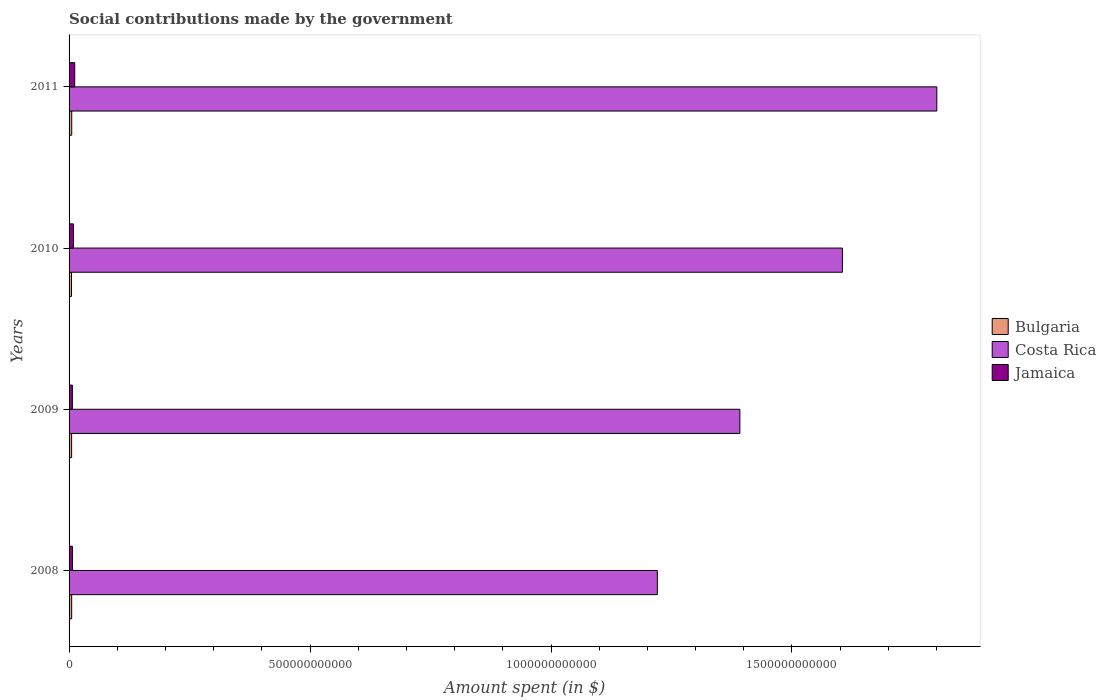How many different coloured bars are there?
Give a very brief answer. 3. How many groups of bars are there?
Offer a terse response. 4. What is the label of the 1st group of bars from the top?
Provide a short and direct response. 2011. In how many cases, is the number of bars for a given year not equal to the number of legend labels?
Offer a very short reply. 0. What is the amount spent on social contributions in Jamaica in 2010?
Make the answer very short. 9.20e+09. Across all years, what is the maximum amount spent on social contributions in Jamaica?
Offer a very short reply. 1.17e+1. Across all years, what is the minimum amount spent on social contributions in Jamaica?
Your response must be concise. 6.87e+09. In which year was the amount spent on social contributions in Costa Rica maximum?
Give a very brief answer. 2011. In which year was the amount spent on social contributions in Costa Rica minimum?
Provide a succinct answer. 2008. What is the total amount spent on social contributions in Jamaica in the graph?
Provide a short and direct response. 3.48e+1. What is the difference between the amount spent on social contributions in Bulgaria in 2008 and that in 2011?
Your answer should be very brief. -1.40e+08. What is the difference between the amount spent on social contributions in Bulgaria in 2010 and the amount spent on social contributions in Costa Rica in 2009?
Give a very brief answer. -1.39e+12. What is the average amount spent on social contributions in Jamaica per year?
Give a very brief answer. 8.71e+09. In the year 2008, what is the difference between the amount spent on social contributions in Costa Rica and amount spent on social contributions in Jamaica?
Make the answer very short. 1.21e+12. In how many years, is the amount spent on social contributions in Jamaica greater than 1100000000000 $?
Offer a terse response. 0. What is the ratio of the amount spent on social contributions in Bulgaria in 2009 to that in 2010?
Your response must be concise. 1.06. What is the difference between the highest and the second highest amount spent on social contributions in Bulgaria?
Give a very brief answer. 1.40e+08. What is the difference between the highest and the lowest amount spent on social contributions in Costa Rica?
Your answer should be compact. 5.80e+11. Is the sum of the amount spent on social contributions in Costa Rica in 2009 and 2011 greater than the maximum amount spent on social contributions in Bulgaria across all years?
Your response must be concise. Yes. What does the 1st bar from the top in 2008 represents?
Provide a succinct answer. Jamaica. What does the 1st bar from the bottom in 2008 represents?
Provide a short and direct response. Bulgaria. Is it the case that in every year, the sum of the amount spent on social contributions in Costa Rica and amount spent on social contributions in Bulgaria is greater than the amount spent on social contributions in Jamaica?
Provide a short and direct response. Yes. How many bars are there?
Your answer should be very brief. 12. Are all the bars in the graph horizontal?
Offer a very short reply. Yes. What is the difference between two consecutive major ticks on the X-axis?
Your answer should be very brief. 5.00e+11. Are the values on the major ticks of X-axis written in scientific E-notation?
Your response must be concise. No. Does the graph contain grids?
Your response must be concise. No. How many legend labels are there?
Your answer should be very brief. 3. How are the legend labels stacked?
Offer a terse response. Vertical. What is the title of the graph?
Your answer should be very brief. Social contributions made by the government. Does "Tanzania" appear as one of the legend labels in the graph?
Ensure brevity in your answer.  No. What is the label or title of the X-axis?
Ensure brevity in your answer.  Amount spent (in $). What is the label or title of the Y-axis?
Offer a very short reply. Years. What is the Amount spent (in $) of Bulgaria in 2008?
Offer a very short reply. 5.39e+09. What is the Amount spent (in $) of Costa Rica in 2008?
Offer a terse response. 1.22e+12. What is the Amount spent (in $) of Jamaica in 2008?
Provide a succinct answer. 7.04e+09. What is the Amount spent (in $) in Bulgaria in 2009?
Your response must be concise. 5.27e+09. What is the Amount spent (in $) in Costa Rica in 2009?
Make the answer very short. 1.39e+12. What is the Amount spent (in $) in Jamaica in 2009?
Provide a short and direct response. 6.87e+09. What is the Amount spent (in $) of Bulgaria in 2010?
Give a very brief answer. 4.97e+09. What is the Amount spent (in $) in Costa Rica in 2010?
Keep it short and to the point. 1.60e+12. What is the Amount spent (in $) in Jamaica in 2010?
Provide a succinct answer. 9.20e+09. What is the Amount spent (in $) of Bulgaria in 2011?
Offer a very short reply. 5.53e+09. What is the Amount spent (in $) in Costa Rica in 2011?
Offer a very short reply. 1.80e+12. What is the Amount spent (in $) in Jamaica in 2011?
Give a very brief answer. 1.17e+1. Across all years, what is the maximum Amount spent (in $) of Bulgaria?
Offer a terse response. 5.53e+09. Across all years, what is the maximum Amount spent (in $) of Costa Rica?
Offer a terse response. 1.80e+12. Across all years, what is the maximum Amount spent (in $) of Jamaica?
Keep it short and to the point. 1.17e+1. Across all years, what is the minimum Amount spent (in $) in Bulgaria?
Give a very brief answer. 4.97e+09. Across all years, what is the minimum Amount spent (in $) in Costa Rica?
Your answer should be very brief. 1.22e+12. Across all years, what is the minimum Amount spent (in $) of Jamaica?
Ensure brevity in your answer.  6.87e+09. What is the total Amount spent (in $) in Bulgaria in the graph?
Make the answer very short. 2.12e+1. What is the total Amount spent (in $) in Costa Rica in the graph?
Your answer should be compact. 6.02e+12. What is the total Amount spent (in $) in Jamaica in the graph?
Your answer should be very brief. 3.48e+1. What is the difference between the Amount spent (in $) of Bulgaria in 2008 and that in 2009?
Your answer should be very brief. 1.20e+08. What is the difference between the Amount spent (in $) in Costa Rica in 2008 and that in 2009?
Offer a terse response. -1.71e+11. What is the difference between the Amount spent (in $) in Jamaica in 2008 and that in 2009?
Provide a succinct answer. 1.69e+08. What is the difference between the Amount spent (in $) of Bulgaria in 2008 and that in 2010?
Your answer should be compact. 4.23e+08. What is the difference between the Amount spent (in $) in Costa Rica in 2008 and that in 2010?
Offer a terse response. -3.84e+11. What is the difference between the Amount spent (in $) in Jamaica in 2008 and that in 2010?
Provide a short and direct response. -2.16e+09. What is the difference between the Amount spent (in $) in Bulgaria in 2008 and that in 2011?
Give a very brief answer. -1.40e+08. What is the difference between the Amount spent (in $) in Costa Rica in 2008 and that in 2011?
Offer a terse response. -5.80e+11. What is the difference between the Amount spent (in $) in Jamaica in 2008 and that in 2011?
Offer a terse response. -4.68e+09. What is the difference between the Amount spent (in $) of Bulgaria in 2009 and that in 2010?
Make the answer very short. 3.03e+08. What is the difference between the Amount spent (in $) of Costa Rica in 2009 and that in 2010?
Your answer should be very brief. -2.13e+11. What is the difference between the Amount spent (in $) in Jamaica in 2009 and that in 2010?
Make the answer very short. -2.33e+09. What is the difference between the Amount spent (in $) of Bulgaria in 2009 and that in 2011?
Offer a very short reply. -2.60e+08. What is the difference between the Amount spent (in $) of Costa Rica in 2009 and that in 2011?
Make the answer very short. -4.09e+11. What is the difference between the Amount spent (in $) of Jamaica in 2009 and that in 2011?
Provide a short and direct response. -4.85e+09. What is the difference between the Amount spent (in $) in Bulgaria in 2010 and that in 2011?
Offer a very short reply. -5.63e+08. What is the difference between the Amount spent (in $) of Costa Rica in 2010 and that in 2011?
Provide a succinct answer. -1.96e+11. What is the difference between the Amount spent (in $) in Jamaica in 2010 and that in 2011?
Offer a very short reply. -2.53e+09. What is the difference between the Amount spent (in $) in Bulgaria in 2008 and the Amount spent (in $) in Costa Rica in 2009?
Provide a short and direct response. -1.39e+12. What is the difference between the Amount spent (in $) of Bulgaria in 2008 and the Amount spent (in $) of Jamaica in 2009?
Give a very brief answer. -1.48e+09. What is the difference between the Amount spent (in $) of Costa Rica in 2008 and the Amount spent (in $) of Jamaica in 2009?
Your response must be concise. 1.21e+12. What is the difference between the Amount spent (in $) in Bulgaria in 2008 and the Amount spent (in $) in Costa Rica in 2010?
Your response must be concise. -1.60e+12. What is the difference between the Amount spent (in $) in Bulgaria in 2008 and the Amount spent (in $) in Jamaica in 2010?
Give a very brief answer. -3.81e+09. What is the difference between the Amount spent (in $) of Costa Rica in 2008 and the Amount spent (in $) of Jamaica in 2010?
Your answer should be very brief. 1.21e+12. What is the difference between the Amount spent (in $) of Bulgaria in 2008 and the Amount spent (in $) of Costa Rica in 2011?
Give a very brief answer. -1.80e+12. What is the difference between the Amount spent (in $) of Bulgaria in 2008 and the Amount spent (in $) of Jamaica in 2011?
Offer a very short reply. -6.34e+09. What is the difference between the Amount spent (in $) in Costa Rica in 2008 and the Amount spent (in $) in Jamaica in 2011?
Offer a very short reply. 1.21e+12. What is the difference between the Amount spent (in $) of Bulgaria in 2009 and the Amount spent (in $) of Costa Rica in 2010?
Your response must be concise. -1.60e+12. What is the difference between the Amount spent (in $) in Bulgaria in 2009 and the Amount spent (in $) in Jamaica in 2010?
Your answer should be very brief. -3.93e+09. What is the difference between the Amount spent (in $) in Costa Rica in 2009 and the Amount spent (in $) in Jamaica in 2010?
Offer a very short reply. 1.38e+12. What is the difference between the Amount spent (in $) in Bulgaria in 2009 and the Amount spent (in $) in Costa Rica in 2011?
Give a very brief answer. -1.80e+12. What is the difference between the Amount spent (in $) of Bulgaria in 2009 and the Amount spent (in $) of Jamaica in 2011?
Your response must be concise. -6.45e+09. What is the difference between the Amount spent (in $) of Costa Rica in 2009 and the Amount spent (in $) of Jamaica in 2011?
Provide a short and direct response. 1.38e+12. What is the difference between the Amount spent (in $) in Bulgaria in 2010 and the Amount spent (in $) in Costa Rica in 2011?
Your response must be concise. -1.80e+12. What is the difference between the Amount spent (in $) of Bulgaria in 2010 and the Amount spent (in $) of Jamaica in 2011?
Offer a terse response. -6.76e+09. What is the difference between the Amount spent (in $) of Costa Rica in 2010 and the Amount spent (in $) of Jamaica in 2011?
Your response must be concise. 1.59e+12. What is the average Amount spent (in $) of Bulgaria per year?
Provide a succinct answer. 5.29e+09. What is the average Amount spent (in $) in Costa Rica per year?
Offer a terse response. 1.50e+12. What is the average Amount spent (in $) in Jamaica per year?
Offer a terse response. 8.71e+09. In the year 2008, what is the difference between the Amount spent (in $) in Bulgaria and Amount spent (in $) in Costa Rica?
Provide a succinct answer. -1.22e+12. In the year 2008, what is the difference between the Amount spent (in $) of Bulgaria and Amount spent (in $) of Jamaica?
Provide a short and direct response. -1.65e+09. In the year 2008, what is the difference between the Amount spent (in $) in Costa Rica and Amount spent (in $) in Jamaica?
Make the answer very short. 1.21e+12. In the year 2009, what is the difference between the Amount spent (in $) in Bulgaria and Amount spent (in $) in Costa Rica?
Offer a terse response. -1.39e+12. In the year 2009, what is the difference between the Amount spent (in $) in Bulgaria and Amount spent (in $) in Jamaica?
Your response must be concise. -1.60e+09. In the year 2009, what is the difference between the Amount spent (in $) of Costa Rica and Amount spent (in $) of Jamaica?
Keep it short and to the point. 1.39e+12. In the year 2010, what is the difference between the Amount spent (in $) in Bulgaria and Amount spent (in $) in Costa Rica?
Give a very brief answer. -1.60e+12. In the year 2010, what is the difference between the Amount spent (in $) in Bulgaria and Amount spent (in $) in Jamaica?
Make the answer very short. -4.23e+09. In the year 2010, what is the difference between the Amount spent (in $) of Costa Rica and Amount spent (in $) of Jamaica?
Make the answer very short. 1.60e+12. In the year 2011, what is the difference between the Amount spent (in $) of Bulgaria and Amount spent (in $) of Costa Rica?
Your answer should be very brief. -1.80e+12. In the year 2011, what is the difference between the Amount spent (in $) in Bulgaria and Amount spent (in $) in Jamaica?
Your answer should be compact. -6.20e+09. In the year 2011, what is the difference between the Amount spent (in $) of Costa Rica and Amount spent (in $) of Jamaica?
Give a very brief answer. 1.79e+12. What is the ratio of the Amount spent (in $) of Bulgaria in 2008 to that in 2009?
Provide a succinct answer. 1.02. What is the ratio of the Amount spent (in $) in Costa Rica in 2008 to that in 2009?
Keep it short and to the point. 0.88. What is the ratio of the Amount spent (in $) of Jamaica in 2008 to that in 2009?
Keep it short and to the point. 1.02. What is the ratio of the Amount spent (in $) of Bulgaria in 2008 to that in 2010?
Offer a very short reply. 1.09. What is the ratio of the Amount spent (in $) of Costa Rica in 2008 to that in 2010?
Provide a succinct answer. 0.76. What is the ratio of the Amount spent (in $) of Jamaica in 2008 to that in 2010?
Offer a very short reply. 0.77. What is the ratio of the Amount spent (in $) in Bulgaria in 2008 to that in 2011?
Ensure brevity in your answer.  0.97. What is the ratio of the Amount spent (in $) in Costa Rica in 2008 to that in 2011?
Your answer should be compact. 0.68. What is the ratio of the Amount spent (in $) in Jamaica in 2008 to that in 2011?
Your response must be concise. 0.6. What is the ratio of the Amount spent (in $) in Bulgaria in 2009 to that in 2010?
Offer a terse response. 1.06. What is the ratio of the Amount spent (in $) in Costa Rica in 2009 to that in 2010?
Your answer should be compact. 0.87. What is the ratio of the Amount spent (in $) in Jamaica in 2009 to that in 2010?
Your response must be concise. 0.75. What is the ratio of the Amount spent (in $) of Bulgaria in 2009 to that in 2011?
Make the answer very short. 0.95. What is the ratio of the Amount spent (in $) in Costa Rica in 2009 to that in 2011?
Give a very brief answer. 0.77. What is the ratio of the Amount spent (in $) in Jamaica in 2009 to that in 2011?
Ensure brevity in your answer.  0.59. What is the ratio of the Amount spent (in $) of Bulgaria in 2010 to that in 2011?
Offer a terse response. 0.9. What is the ratio of the Amount spent (in $) of Costa Rica in 2010 to that in 2011?
Provide a succinct answer. 0.89. What is the ratio of the Amount spent (in $) in Jamaica in 2010 to that in 2011?
Offer a terse response. 0.78. What is the difference between the highest and the second highest Amount spent (in $) in Bulgaria?
Provide a succinct answer. 1.40e+08. What is the difference between the highest and the second highest Amount spent (in $) in Costa Rica?
Offer a terse response. 1.96e+11. What is the difference between the highest and the second highest Amount spent (in $) of Jamaica?
Provide a short and direct response. 2.53e+09. What is the difference between the highest and the lowest Amount spent (in $) of Bulgaria?
Offer a terse response. 5.63e+08. What is the difference between the highest and the lowest Amount spent (in $) in Costa Rica?
Ensure brevity in your answer.  5.80e+11. What is the difference between the highest and the lowest Amount spent (in $) of Jamaica?
Make the answer very short. 4.85e+09. 